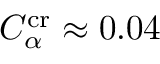<formula> <loc_0><loc_0><loc_500><loc_500>C _ { \alpha } ^ { c r } \approx 0 . 0 4</formula> 